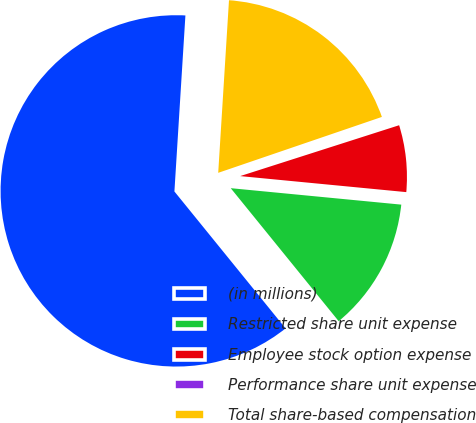Convert chart. <chart><loc_0><loc_0><loc_500><loc_500><pie_chart><fcel>(in millions)<fcel>Restricted share unit expense<fcel>Employee stock option expense<fcel>Performance share unit expense<fcel>Total share-based compensation<nl><fcel>61.85%<fcel>12.62%<fcel>6.46%<fcel>0.31%<fcel>18.77%<nl></chart> 